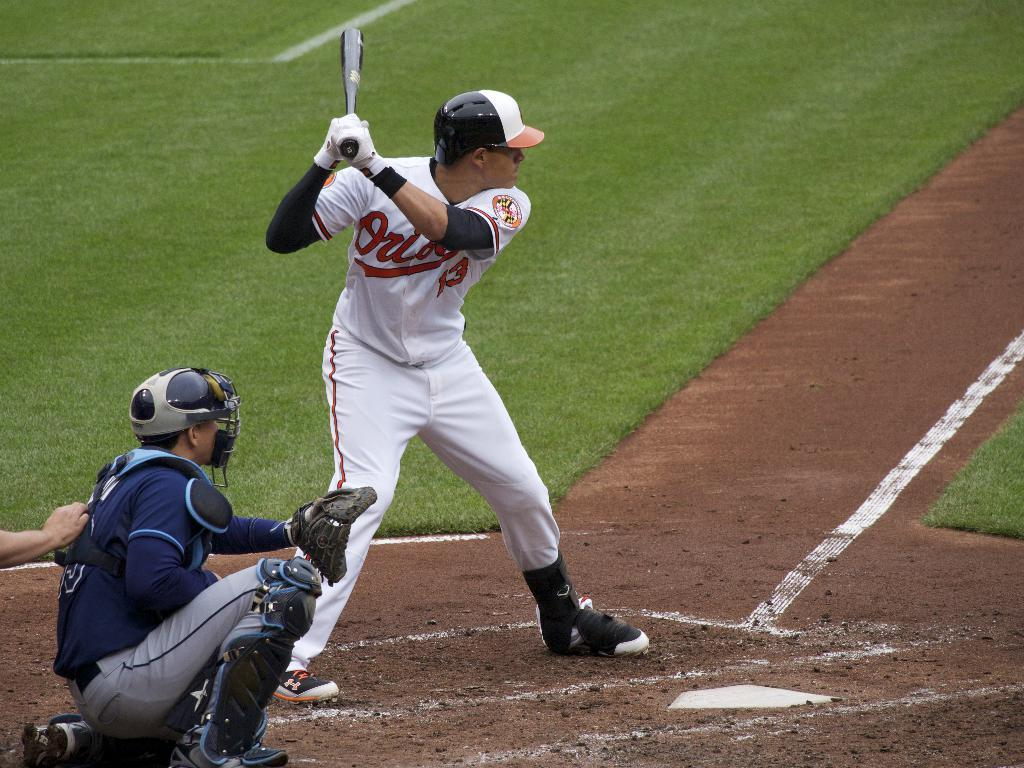Provide a one-sentence caption for the provided image. A batter for the Baltimore Orioles stands at the plate. 